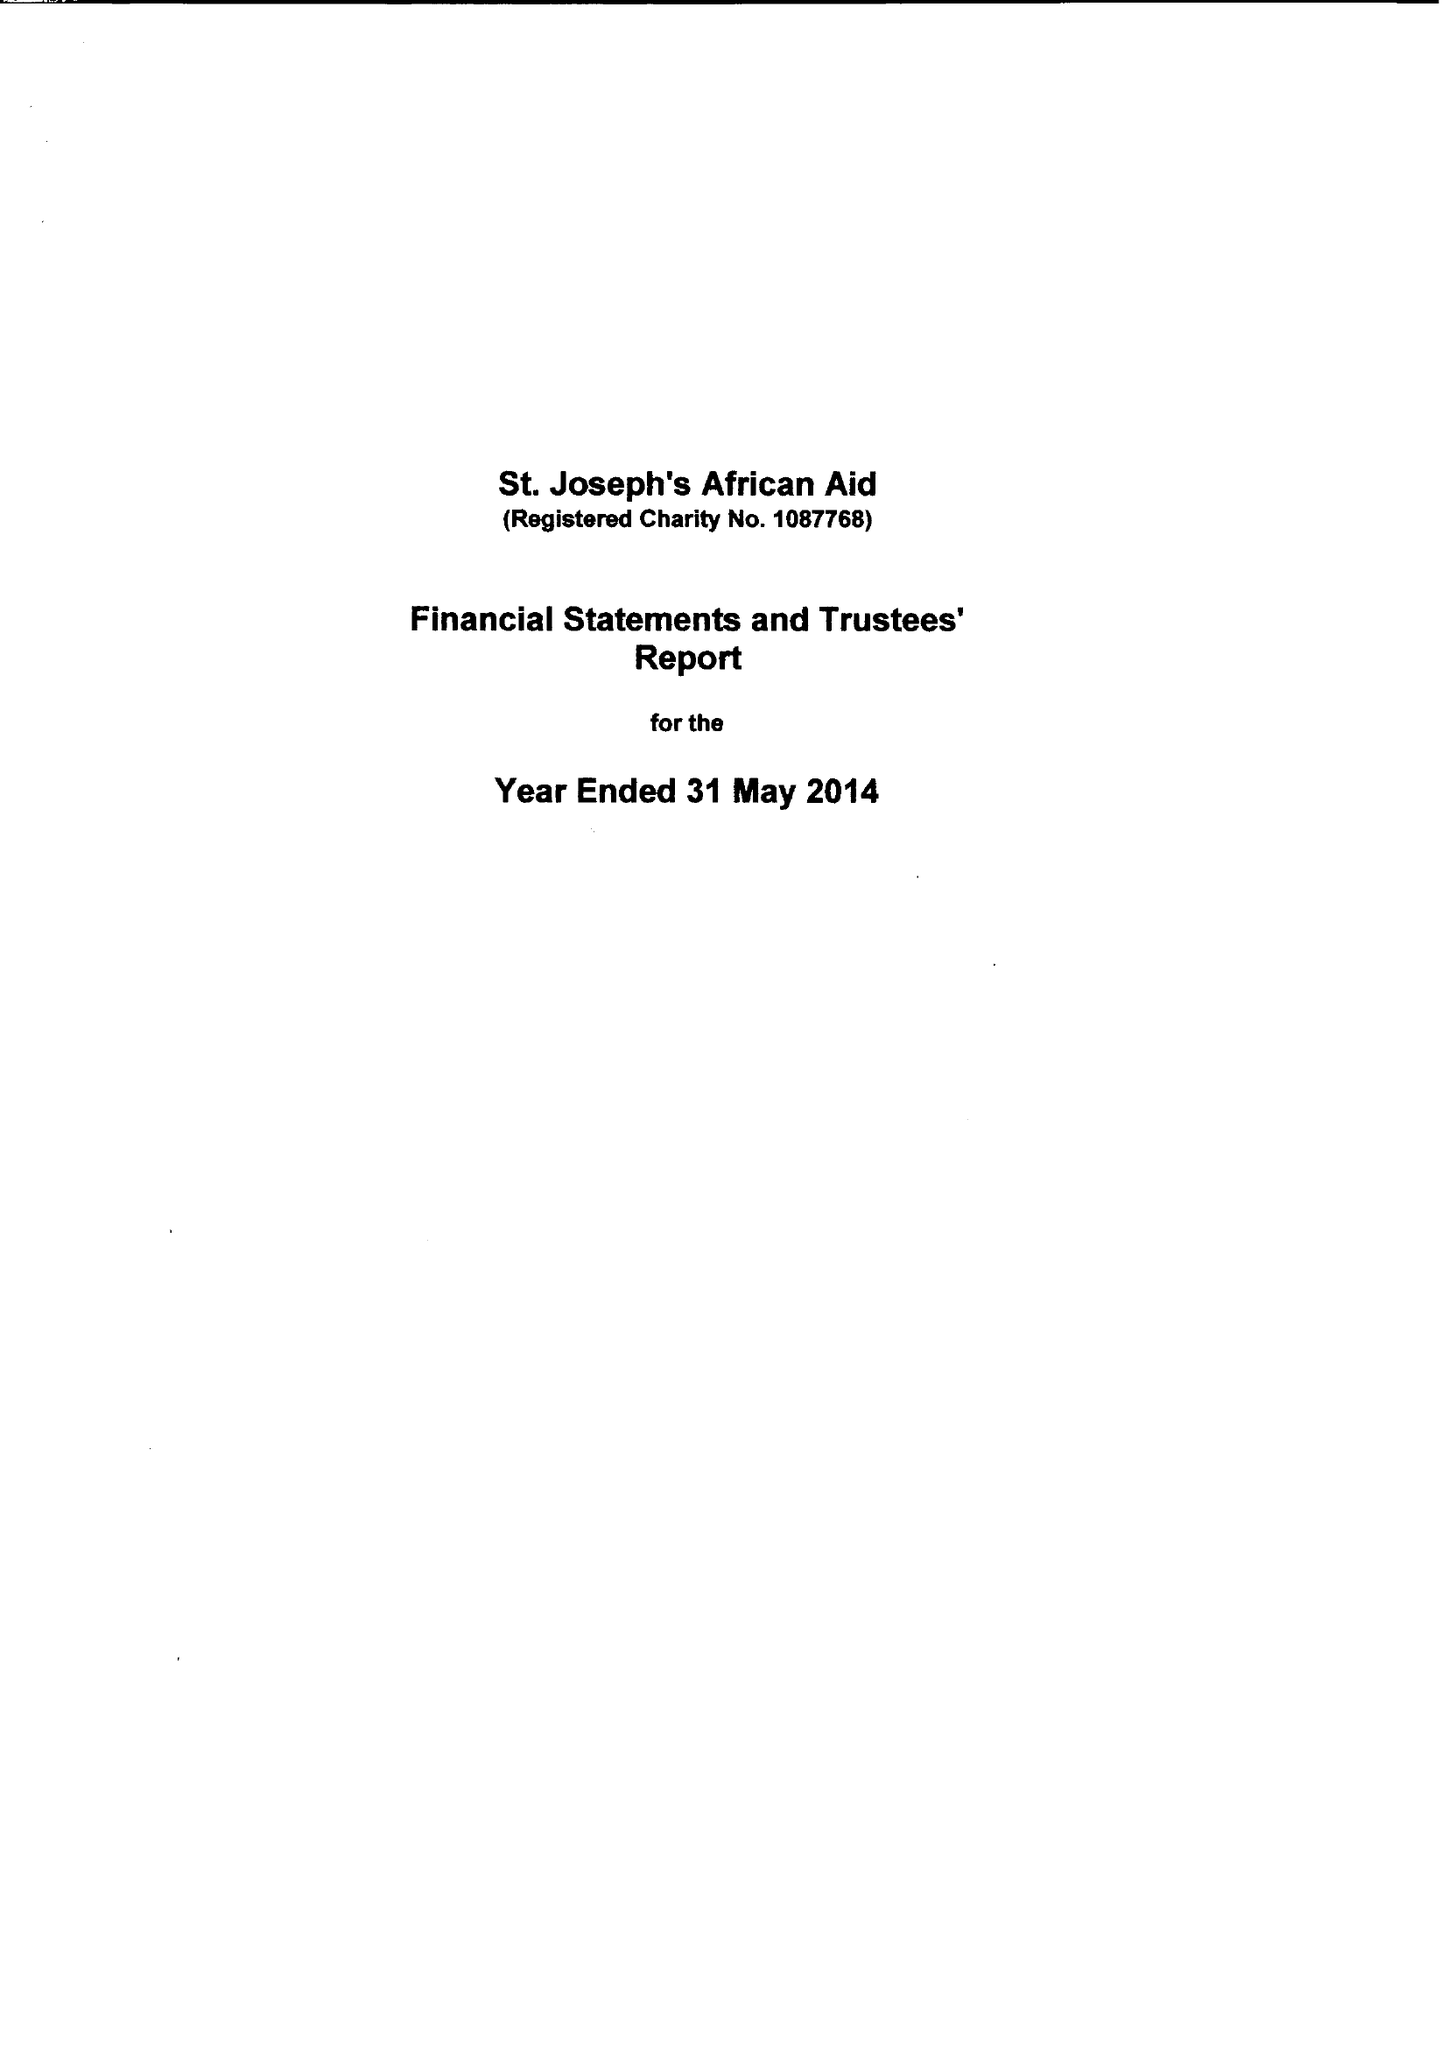What is the value for the address__post_town?
Answer the question using a single word or phrase. STAINES-UPON-THAMES[11] 